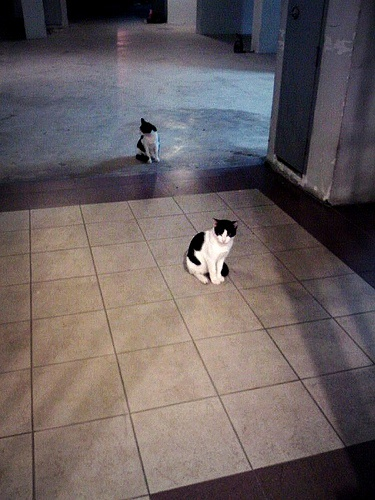Describe the objects in this image and their specific colors. I can see cat in black, white, and darkgray tones and cat in black and gray tones in this image. 